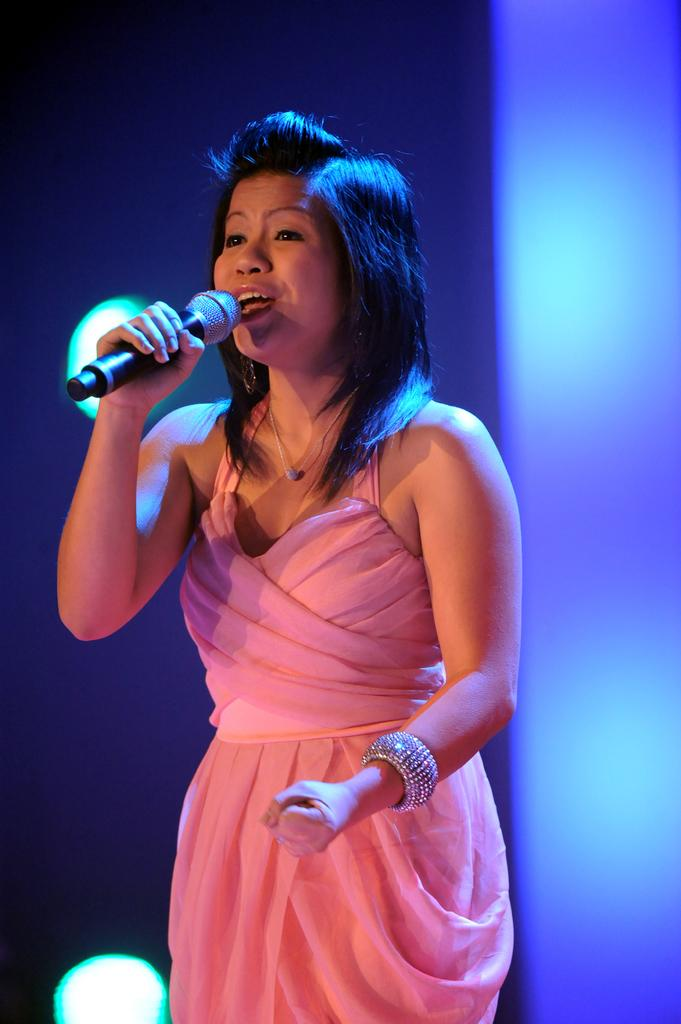Who is the main subject in the image? There is a woman in the image. What is the woman holding in the image? The woman is holding a mic. What type of liquid is being poured into the mic in the image? There is no liquid being poured into the mic in the image; the woman is simply holding a mic. 